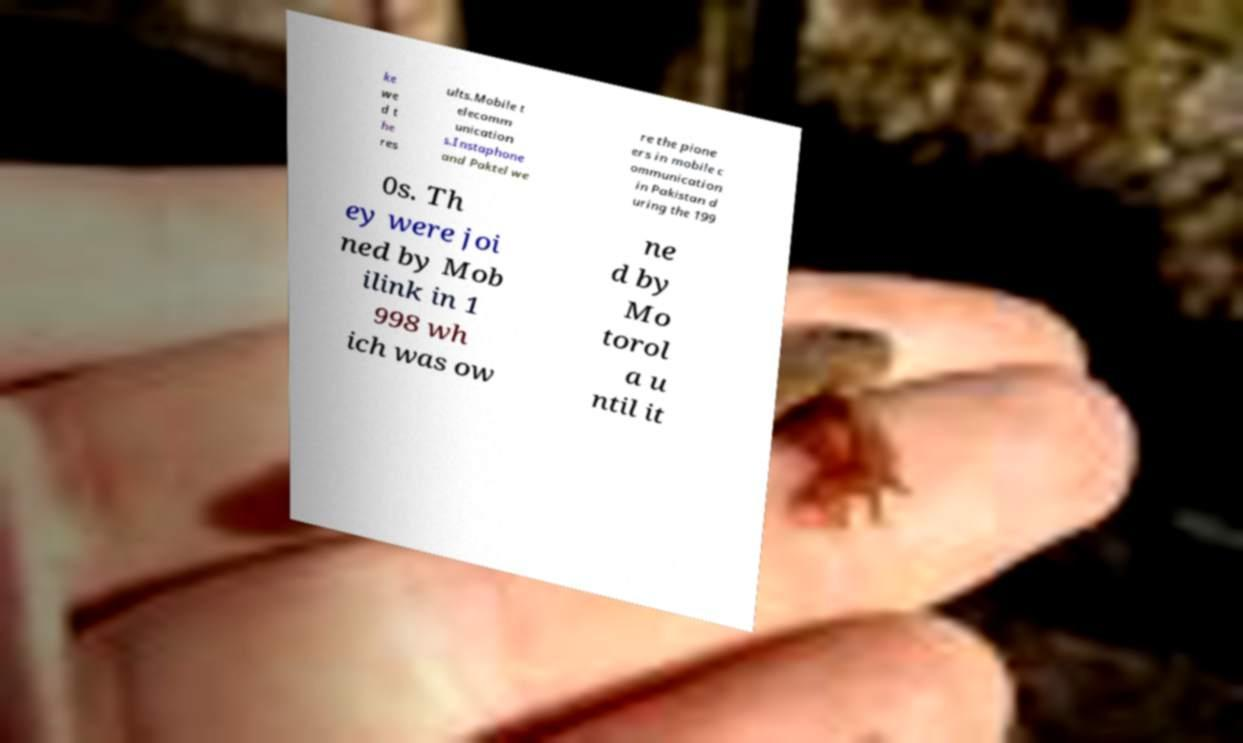Please read and relay the text visible in this image. What does it say? ke we d t he res ults.Mobile t elecomm unication s.Instaphone and Paktel we re the pione ers in mobile c ommunication in Pakistan d uring the 199 0s. Th ey were joi ned by Mob ilink in 1 998 wh ich was ow ne d by Mo torol a u ntil it 